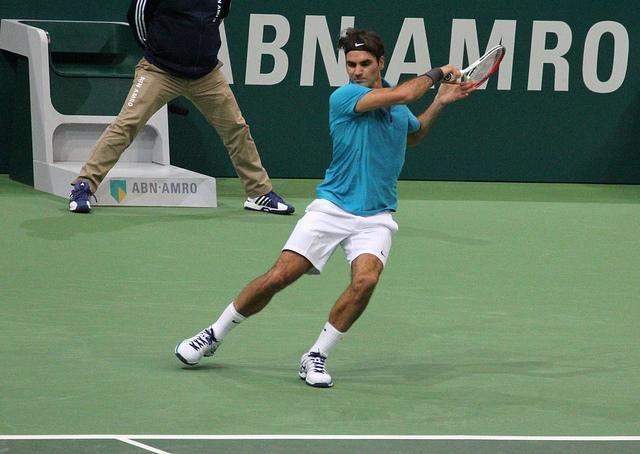How many people are there?
Give a very brief answer. 2. 